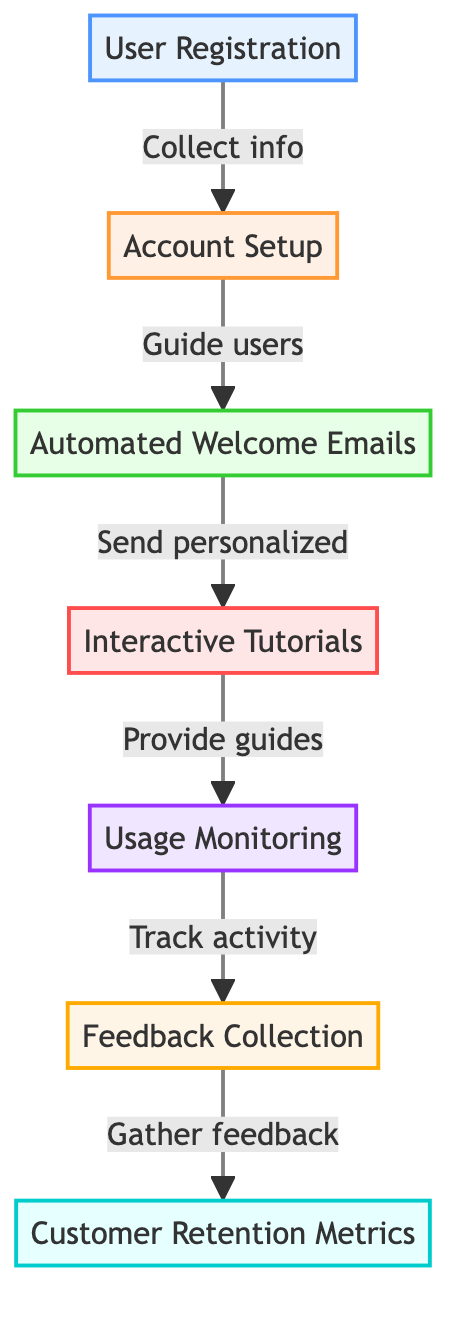What is the first step in the onboarding process? The first step is 'User Registration,' which involves collecting necessary user information through a digital registration form.
Answer: User Registration How many total nodes are in the diagram? The diagram contains a total of seven nodes, which represent different stages of the customer onboarding process.
Answer: Seven What action follows the Account Setup? After the Account Setup, the action that follows is sending 'Automated Welcome Emails' to the users.
Answer: Automated Welcome Emails Which node is responsible for tracking user activity? The node responsible for tracking user activity is 'Usage Monitoring,' which involves using data analytics tools to monitor user interactions.
Answer: Usage Monitoring Which two nodes are directly linked with arrows in the flowchart? The 'Feedback Collection' node is directly linked with the 'Usage Monitoring' node and also leads to the 'Customer Retention Metrics' node.
Answer: Feedback Collection, Customer Retention Metrics What type of node is 'Interactive Tutorials'? The 'Interactive Tutorials' node is a process type, which means it provides step-by-step guides and interactive tutorials to help users understand the platform.
Answer: Process What comes after the collection of user feedback? After the collection of user feedback, the next step is the evaluation of 'Customer Retention Metrics,' which measures customer engagement and satisfaction.
Answer: Customer Retention Metrics How does user registration relate to account setup? 'User Registration' directly feeds into 'Account Setup,' indicating that the user information collected is used to guide the account setup process.
Answer: Account Setup What kind of evaluation metrics are utilized at the final stage? At the final stage, 'Customer Retention Metrics' are utilized, focusing on measuring customer engagement, satisfaction, and retention rates.
Answer: Customer Retention Metrics 